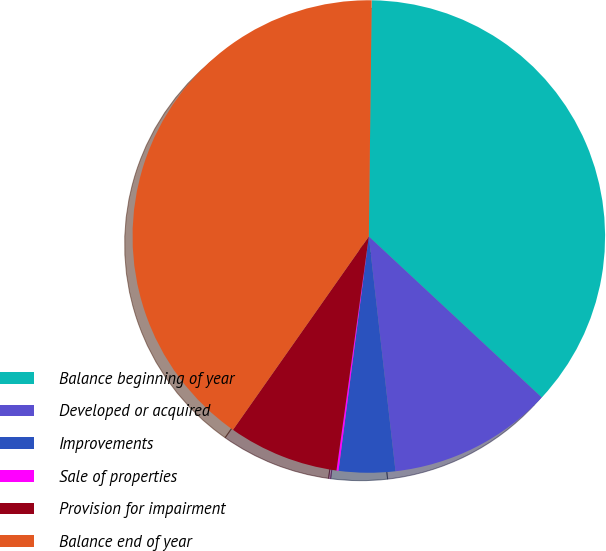Convert chart. <chart><loc_0><loc_0><loc_500><loc_500><pie_chart><fcel>Balance beginning of year<fcel>Developed or acquired<fcel>Improvements<fcel>Sale of properties<fcel>Provision for impairment<fcel>Balance end of year<nl><fcel>36.74%<fcel>11.27%<fcel>3.85%<fcel>0.14%<fcel>7.56%<fcel>40.45%<nl></chart> 